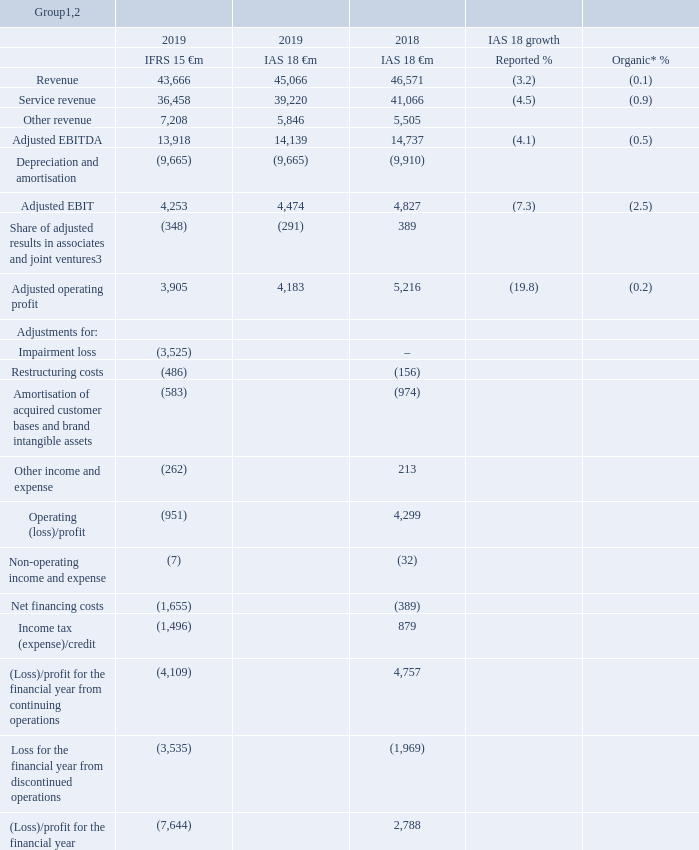Our financial performance
This section presents our operating performance, providing commentary on how the revenue and the adjusted EBITDA performance of the Group and its operating segments have developed over the last year. Following the adoption of IFRS 15 “Revenue from Contracts with Customers” on 1 April 2018, the Group’s statutory results for the year ended 31 March 2019 are on an IFRS 15 basis, whereas the statutory results for the year ended 31 March 2018 are on an IAS 18 basis as previously reported, with any comparison between the two bases of reporting not being meaningful. As a result, the discussion of our operating financial performance is primarily on an IAS 18 basis for all years presented. See “Alternative performance measures” on page 231 for more information and reconciliations to the closest respective equivalent GAAP measures.
Notes:
* All amounts in the Our financial performance section marked with an “*” represent organic growth which presents performance on a comparable basis, both in terms of merger and acquisition activity and movements in foreign exchange rates. Organic growth is an alternative performance measure. See “Alternative performance measures” on page 231 for further details and reconciliations to the respective closest equivalent GAAP measure.
Revenue and service revenue include the regional results of Europe, Rest of the World, Other (which includes the results of partner market activities) and eliminations. The 2019 results reflect average foreign exchange rates of €1:£0.88, €1:INR 80.93, €1:ZAR 15.92, €1:TKL 6.05 and €1: EGP 20.61.
2 Service revenue, adjusted EBITDA, adjusted EBIT and adjusted operating profit are alternative performance measures. Alternative performance measures are non-GAAP measures that are presented to provide readers with additional financial information that is regularly reviewed by management and should not be viewed in isolation or as an alternative to the equivalent GAAP measures. See “Alternative performance measures” on page 231 for more information and reconciliations to the closest respective equivalent GAAP measure and “Definition of terms” on page 250 for further details.
3 Share of adjusted results in equity accounted associates and joint ventures excludes amortisation of acquired customer bases and brand intangible assets, restructuring costs and other costs of €0.6 billion which are included in amortisation of acquired customer base and brand intangible assets, restructuring costs and other income and expense respectively.
Which accounting standard was the Group's 2019 statutory results based on? Ifrs 15. Which accounting standard was the Group's 2018 statutory results based on? Ias 18. How much was the 2019 IAS 18 service revenue (in €m) ?
Answer scale should be: million. 39,220. What is the average service revenue between 2018 and 2019 IAS 18?
Answer scale should be: million. (39,220+41,066)/2
Answer: 40143. In 2019 IAS 18, which was the higher revenue segment? 39,220>5,846
Answer: service revenue. What is the difference between average service revenue and average other revenue?
Answer scale should be: million. [(39,220+41,066)/2] - [(5,846+5,505)/2]
Answer: 34467.5. 